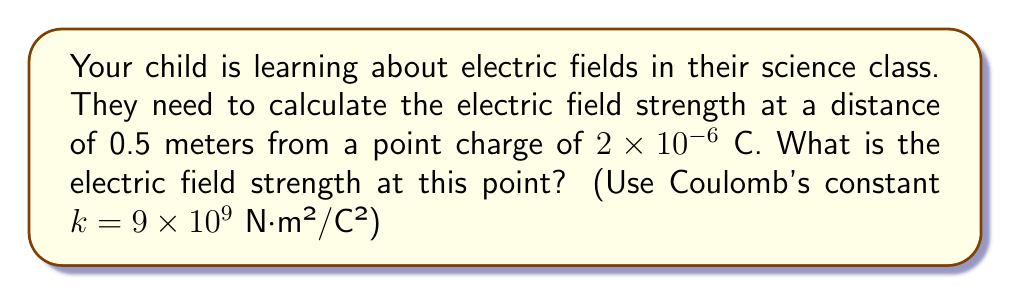Show me your answer to this math problem. Let's approach this step-by-step:

1) The formula for electric field strength (E) due to a point charge is:

   $$E = k \frac{q}{r^2}$$

   Where:
   - $k$ is Coulomb's constant
   - $q$ is the charge
   - $r$ is the distance from the charge

2) We're given:
   - $k = 9 \times 10^9$ N⋅m²/C²
   - $q = 2 \times 10^{-6}$ C
   - $r = 0.5$ m

3) Let's substitute these values into the formula:

   $$E = (9 \times 10^9) \frac{2 \times 10^{-6}}{(0.5)^2}$$

4) First, let's calculate the denominator:
   $(0.5)^2 = 0.25$

5) Now our equation looks like:

   $$E = (9 \times 10^9) \frac{2 \times 10^{-6}}{0.25}$$

6) Divide $2 \times 10^{-6}$ by 0.25:
   $\frac{2 \times 10^{-6}}{0.25} = 8 \times 10^{-6}$

7) Our equation is now:

   $$E = (9 \times 10^9)(8 \times 10^{-6})$$

8) Multiply:
   $9 \times 8 = 72$
   $10^9 \times 10^{-6} = 10^3$

   So, $E = 72 \times 10^3 = 72,000$ N/C
Answer: 72,000 N/C 